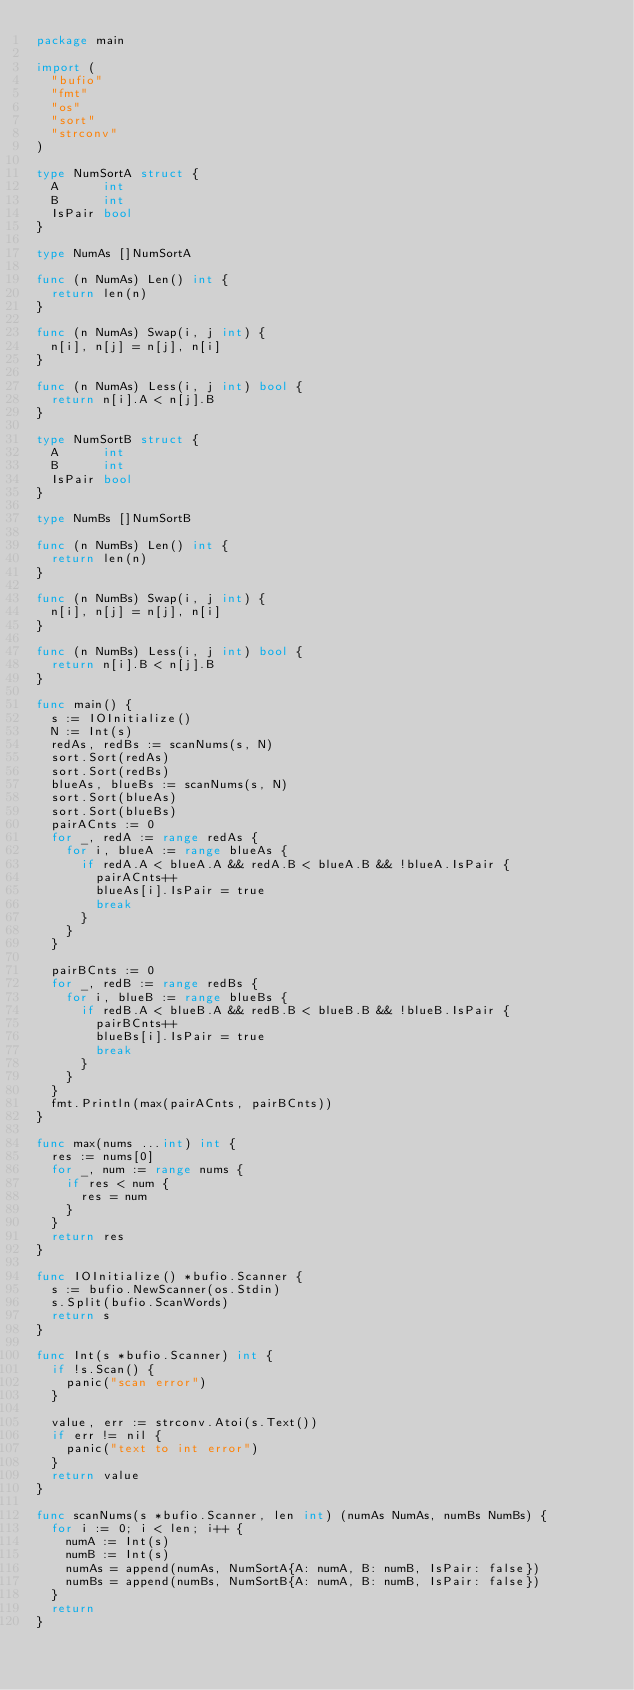Convert code to text. <code><loc_0><loc_0><loc_500><loc_500><_Go_>package main

import (
	"bufio"
	"fmt"
	"os"
	"sort"
	"strconv"
)

type NumSortA struct {
	A      int
	B      int
	IsPair bool
}

type NumAs []NumSortA

func (n NumAs) Len() int {
	return len(n)
}

func (n NumAs) Swap(i, j int) {
	n[i], n[j] = n[j], n[i]
}

func (n NumAs) Less(i, j int) bool {
	return n[i].A < n[j].B
}

type NumSortB struct {
	A      int
	B      int
	IsPair bool
}

type NumBs []NumSortB

func (n NumBs) Len() int {
	return len(n)
}

func (n NumBs) Swap(i, j int) {
	n[i], n[j] = n[j], n[i]
}

func (n NumBs) Less(i, j int) bool {
	return n[i].B < n[j].B
}

func main() {
	s := IOInitialize()
	N := Int(s)
	redAs, redBs := scanNums(s, N)
	sort.Sort(redAs)
	sort.Sort(redBs)
	blueAs, blueBs := scanNums(s, N)
	sort.Sort(blueAs)
	sort.Sort(blueBs)
	pairACnts := 0
	for _, redA := range redAs {
		for i, blueA := range blueAs {
			if redA.A < blueA.A && redA.B < blueA.B && !blueA.IsPair {
				pairACnts++
				blueAs[i].IsPair = true
				break
			}
		}
	}

	pairBCnts := 0
	for _, redB := range redBs {
		for i, blueB := range blueBs {
			if redB.A < blueB.A && redB.B < blueB.B && !blueB.IsPair {
				pairBCnts++
				blueBs[i].IsPair = true
				break
			}
		}
	}
	fmt.Println(max(pairACnts, pairBCnts))
}

func max(nums ...int) int {
	res := nums[0]
	for _, num := range nums {
		if res < num {
			res = num
		}
	}
	return res
}

func IOInitialize() *bufio.Scanner {
	s := bufio.NewScanner(os.Stdin)
	s.Split(bufio.ScanWords)
	return s
}

func Int(s *bufio.Scanner) int {
	if !s.Scan() {
		panic("scan error")
	}

	value, err := strconv.Atoi(s.Text())
	if err != nil {
		panic("text to int error")
	}
	return value
}

func scanNums(s *bufio.Scanner, len int) (numAs NumAs, numBs NumBs) {
	for i := 0; i < len; i++ {
		numA := Int(s)
		numB := Int(s)
		numAs = append(numAs, NumSortA{A: numA, B: numB, IsPair: false})
		numBs = append(numBs, NumSortB{A: numA, B: numB, IsPair: false})
	}
	return
}
</code> 